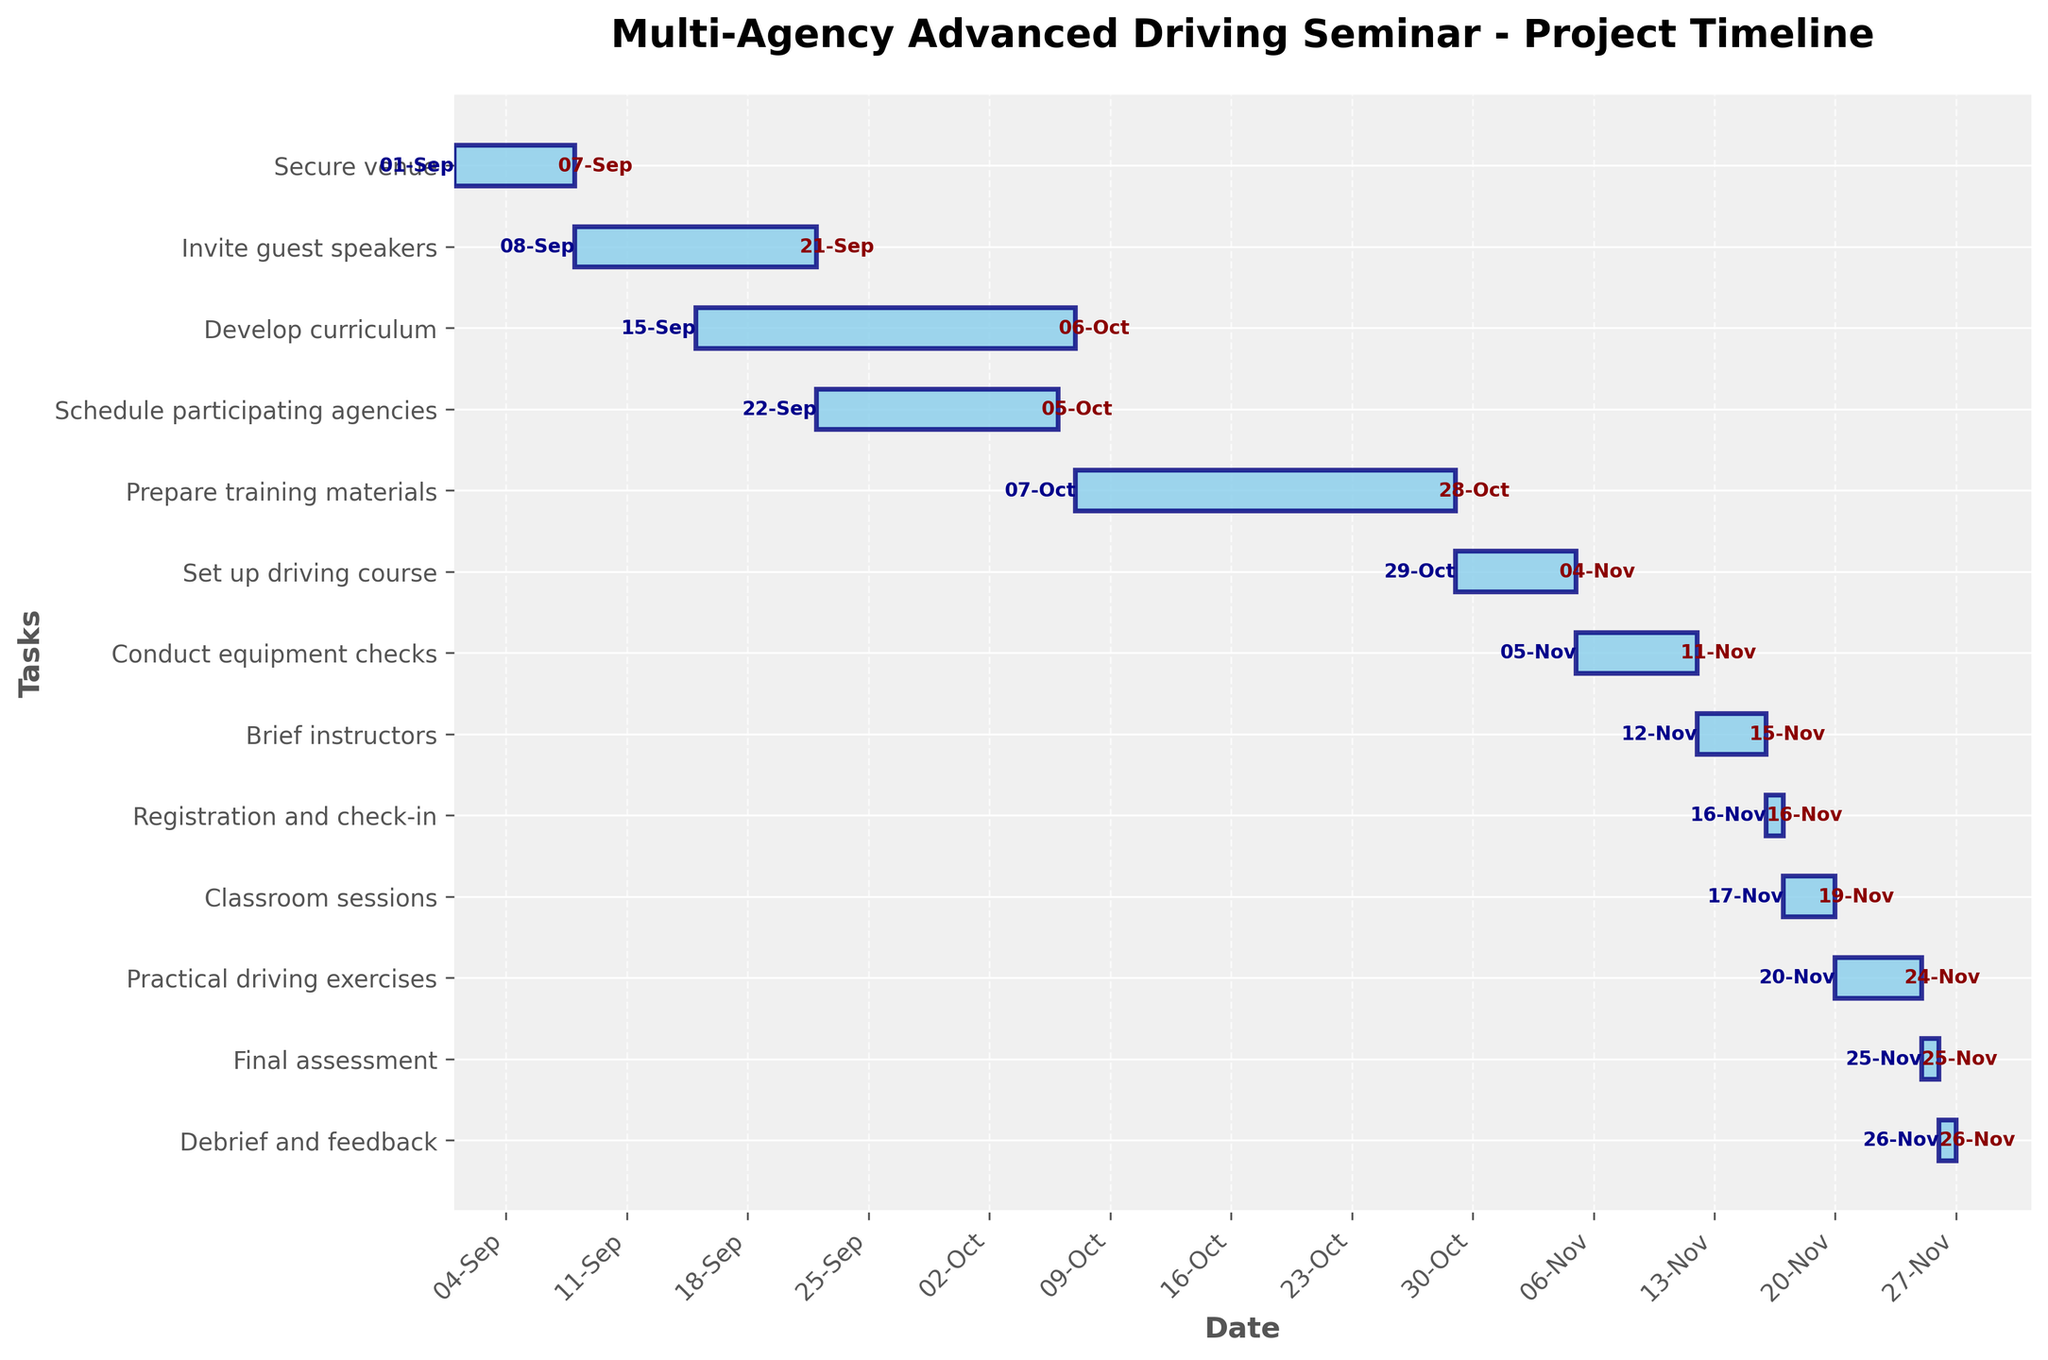What is the title of the Gantt Chart? The title is usually displayed at the top of the chart as text. It provides information about what the Gantt chart is representing.
Answer: Multi-Agency Advanced Driving Seminar - Project Timeline How many tasks are listed in the Gantt Chart? To find the number of tasks, count the labels on the y-axis. Each label corresponds to a task.
Answer: 13 What is the duration of the task 'Develop curriculum'? Identify the bar labeled 'Develop curriculum' and refer to its length in days, typically labeled next to the bar.
Answer: 22 days Which task starts on September 22, 2023? Look for the bar that starts on September 22, 2023, noted next to the start of the bar.
Answer: Schedule participating agencies What is the shortest task, and how long does it last? Identify the smallest bar on the chart and read the associated duration in days.
Answer: Registration and check-in, 1 day When does the 'Set up driving course' task start and end? Locate the 'Set up driving course' bar and check the labels at the start and end of the bar.
Answer: Starts: October 29, Ends: November 4 What is the duration overlap between 'Develop curriculum' and 'Schedule participating agencies'? Find the intersection of the time periods of 'Develop curriculum' (September 15 to October 6) and 'Schedule participating agencies' (September 22 to October 5), then calculate the overlapping period.
Answer: 14 days Which tasks overlap with 'Prepare training materials'? Identify the timeline of 'Prepare training materials' (October 7 to October 28) and check for other bars that intersect this period.
Answer: None Which task finishes immediately before 'Practical driving exercises' starts? Find the end date of 'Practical driving exercises' and look for a task that ends just before this.
Answer: Classroom sessions What are the last three tasks on the Gantt Chart? Review the lower end of the y-axis and read the labels of the last three listed tasks.
Answer: Practical driving exercises, Final assessment, Debrief and feedback 